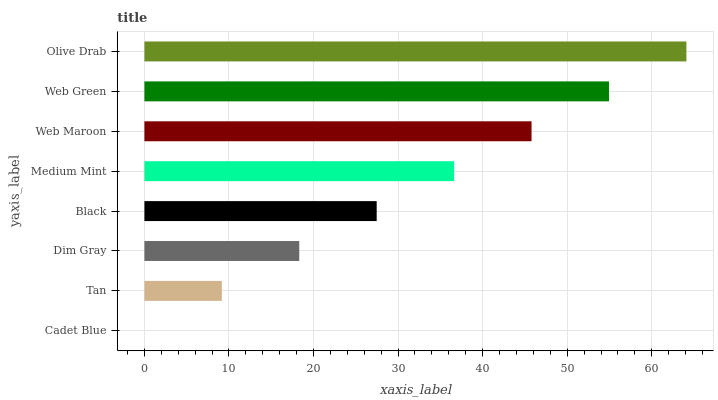Is Cadet Blue the minimum?
Answer yes or no. Yes. Is Olive Drab the maximum?
Answer yes or no. Yes. Is Tan the minimum?
Answer yes or no. No. Is Tan the maximum?
Answer yes or no. No. Is Tan greater than Cadet Blue?
Answer yes or no. Yes. Is Cadet Blue less than Tan?
Answer yes or no. Yes. Is Cadet Blue greater than Tan?
Answer yes or no. No. Is Tan less than Cadet Blue?
Answer yes or no. No. Is Medium Mint the high median?
Answer yes or no. Yes. Is Black the low median?
Answer yes or no. Yes. Is Web Green the high median?
Answer yes or no. No. Is Cadet Blue the low median?
Answer yes or no. No. 